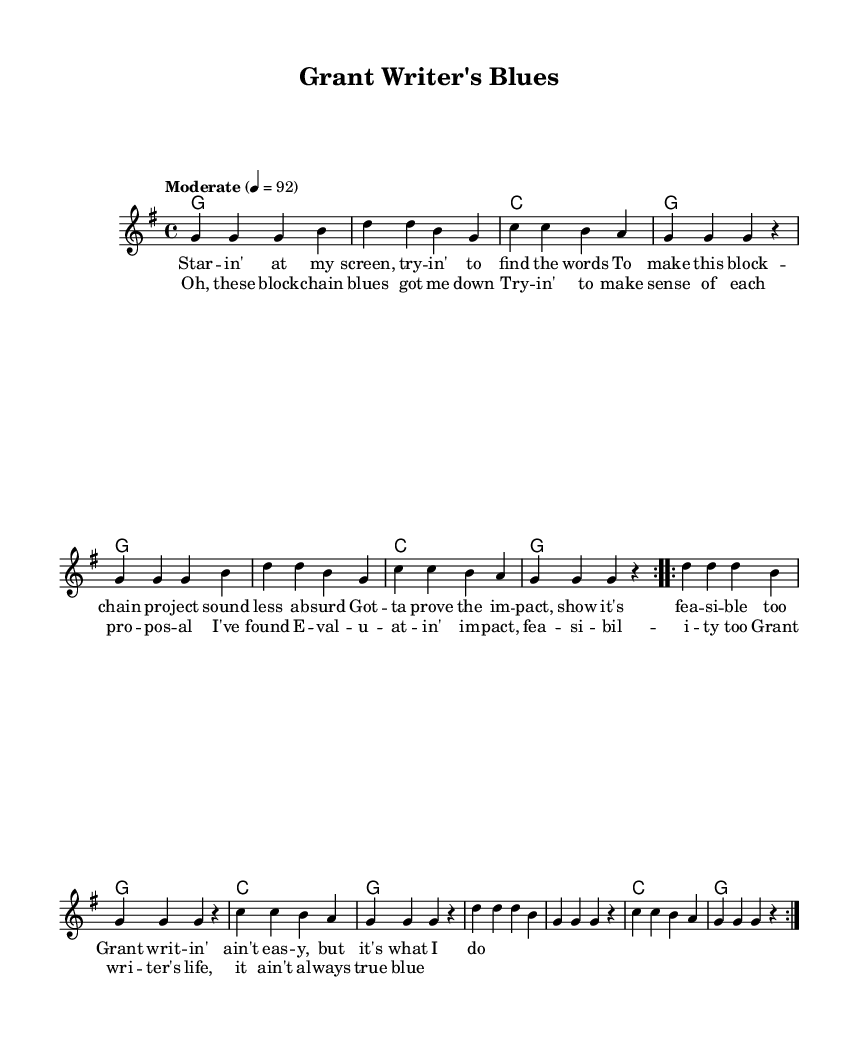What is the key signature of this music? The key signature is G major, which has one sharp (F#). This is indicated at the beginning of the staff.
Answer: G major What is the time signature of this music? The time signature is 4/4, which is shown at the beginning of the score. This means there are four beats per measure.
Answer: 4/4 What is the tempo marking of this piece? The tempo marking indicates "Moderate" with a metronome marking of 92 beats per minute. This sets the speed of the music.
Answer: Moderate 4 = 92 How many verses are included in the song structure? The song structure consists of one verse and a chorus, evidenced by the distinct sections labeled in the lyrics.
Answer: One What is the main focus of the lyrics in this piece? The lyrics focus on the challenges of grant writing and the complexities of blockchain research. This is reflected in the themes discussed throughout the lyrics.
Answer: Grant writing What chord is primarily used in the harmonies? The primary chord used in the harmonies is G major, which is repeated throughout the piece as indicated in the chord section.
Answer: G How many times is the chorus repeated in the piece? The chorus is repeated twice, as indicated by the structure of the repeated sections in the lyrics. This is a common practice in country music to reinforce the main message.
Answer: Twice 